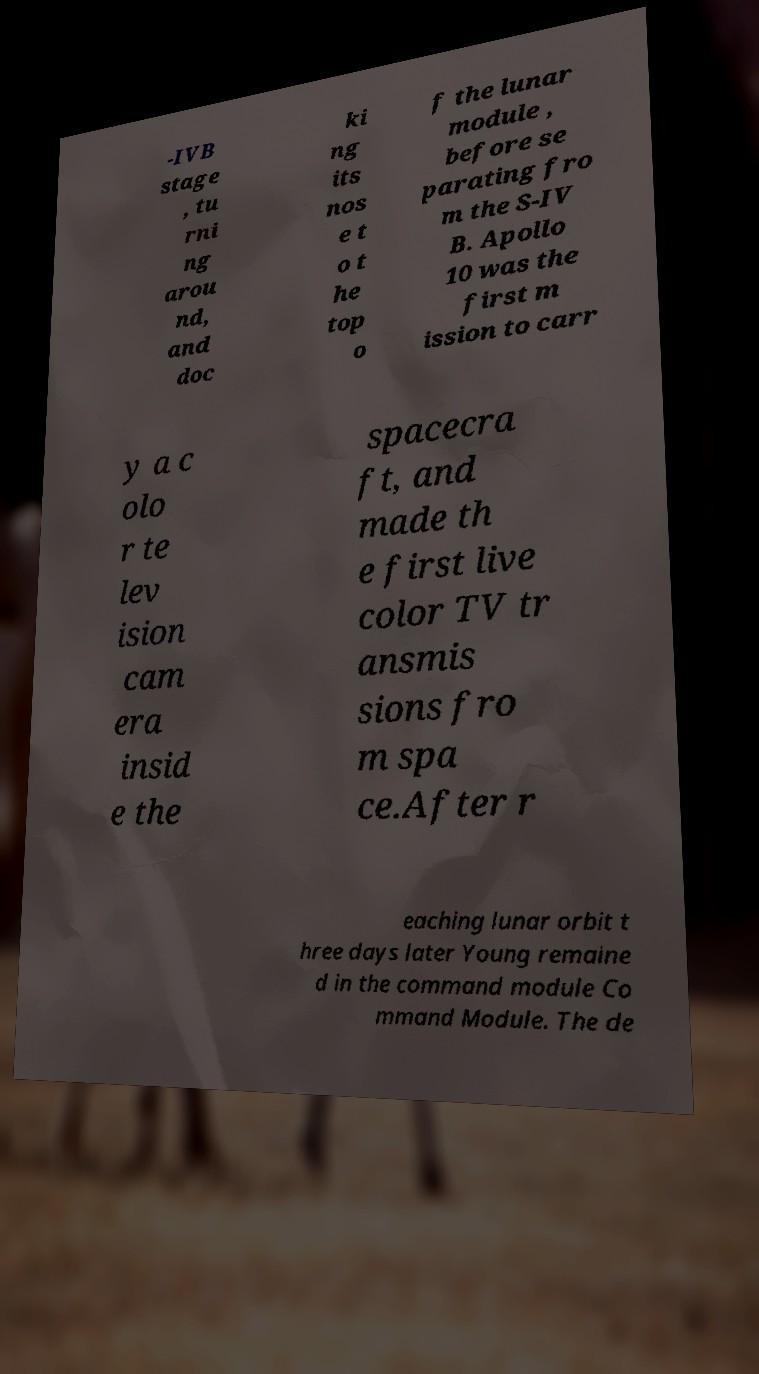Could you assist in decoding the text presented in this image and type it out clearly? -IVB stage , tu rni ng arou nd, and doc ki ng its nos e t o t he top o f the lunar module , before se parating fro m the S-IV B. Apollo 10 was the first m ission to carr y a c olo r te lev ision cam era insid e the spacecra ft, and made th e first live color TV tr ansmis sions fro m spa ce.After r eaching lunar orbit t hree days later Young remaine d in the command module Co mmand Module. The de 